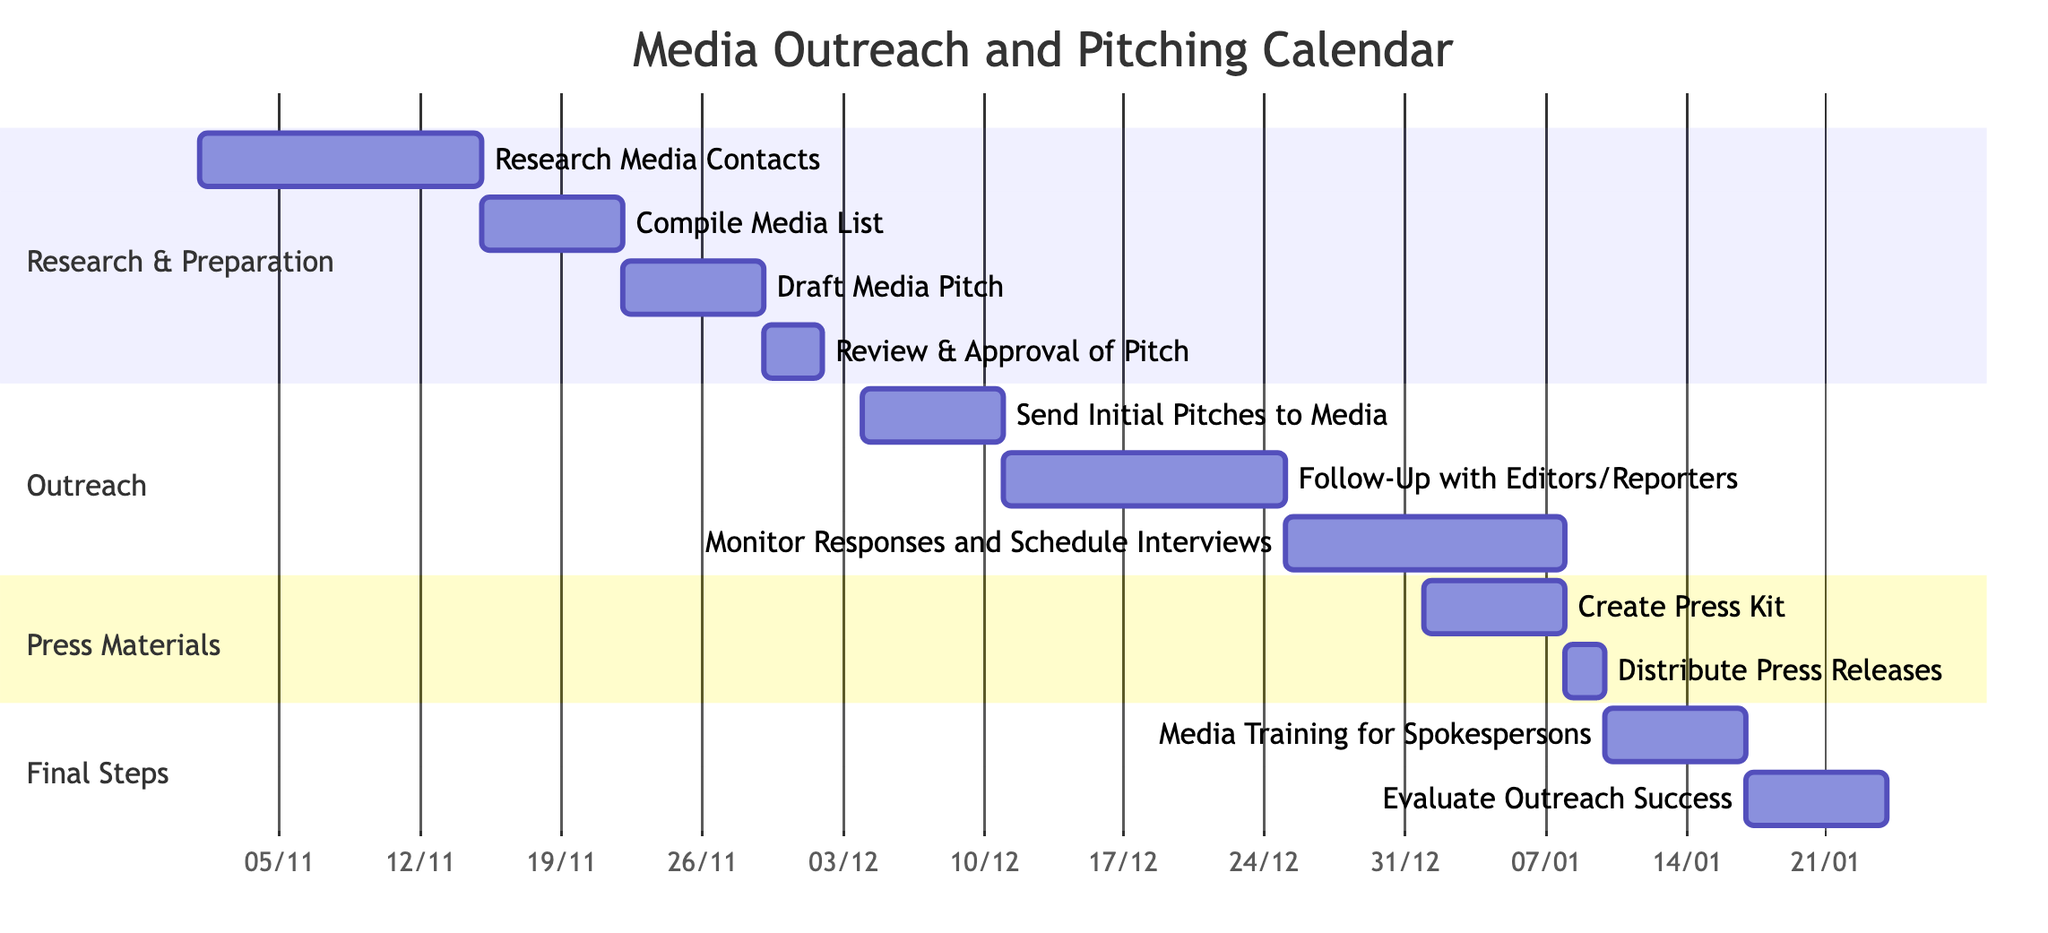What is the total duration for the "Follow-Up with Editors/Reporters"? The duration for this task is listed as 2 weeks in the diagram.
Answer: 2 weeks What task is scheduled immediately after "Draft Media Pitch"? The task immediately following "Draft Media Pitch" is "Review & Approval of Pitch" as per the timeline.
Answer: Review & Approval of Pitch How many tasks are in the "Research & Preparation" section? The section has four tasks: "Research Media Contacts," "Compile Media List," "Draft Media Pitch," and "Review & Approval of Pitch."
Answer: 4 tasks Which task starts on December 25, 2023? "Monitor Responses and Schedule Interviews" starts on December 25, 2023, based on the dates provided.
Answer: Monitor Responses and Schedule Interviews What is the relationship between "Create Press Kit" and "Distribute Press Releases"? "Create Press Kit" occurs before "Distribute Press Releases," as "Create Press Kit" ends on January 7, while "Distribute Press Releases" starts on January 8.
Answer: Before What is the total duration from the beginning of the project until "Distribute Press Releases" is completed? The project starts on November 1, 2023, and "Distribute Press Releases" completes on January 9, 2024, providing a total duration of about 10 weeks.
Answer: 10 weeks What is the last task listed in the Gantt chart? The last task is "Evaluate Outreach Success," which follows the media training task.
Answer: Evaluate Outreach Success How many weeks are allocated for the "Media Training for Spokespersons"? The duration allocated for this task is 1 week as per the schedule.
Answer: 1 week 